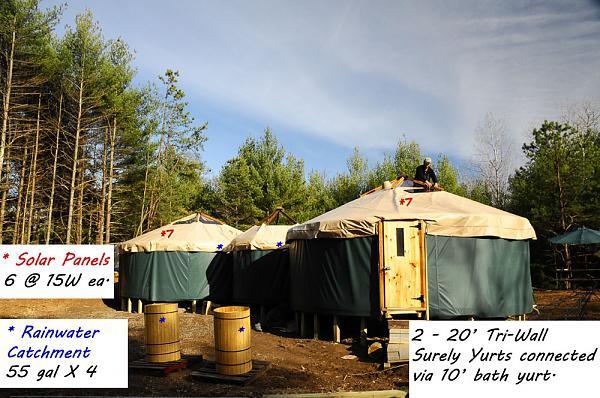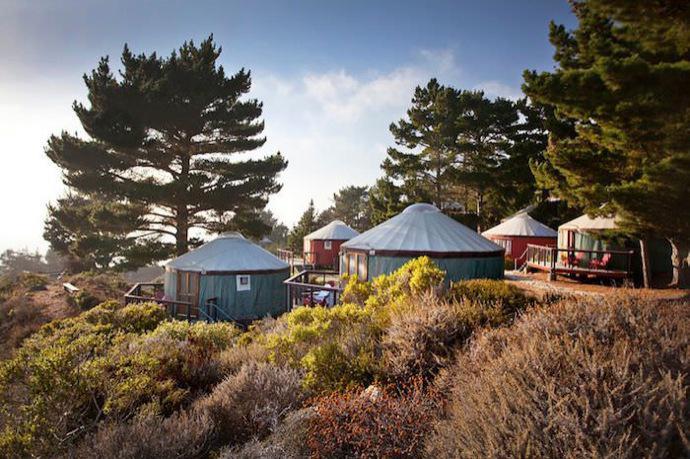The first image is the image on the left, the second image is the image on the right. Given the left and right images, does the statement "At least one image shows a walkway and railing leading to a yurt." hold true? Answer yes or no. No. The first image is the image on the left, the second image is the image on the right. Analyze the images presented: Is the assertion "In one image, green round houses with light colored roofs are near tall pine trees." valid? Answer yes or no. Yes. 